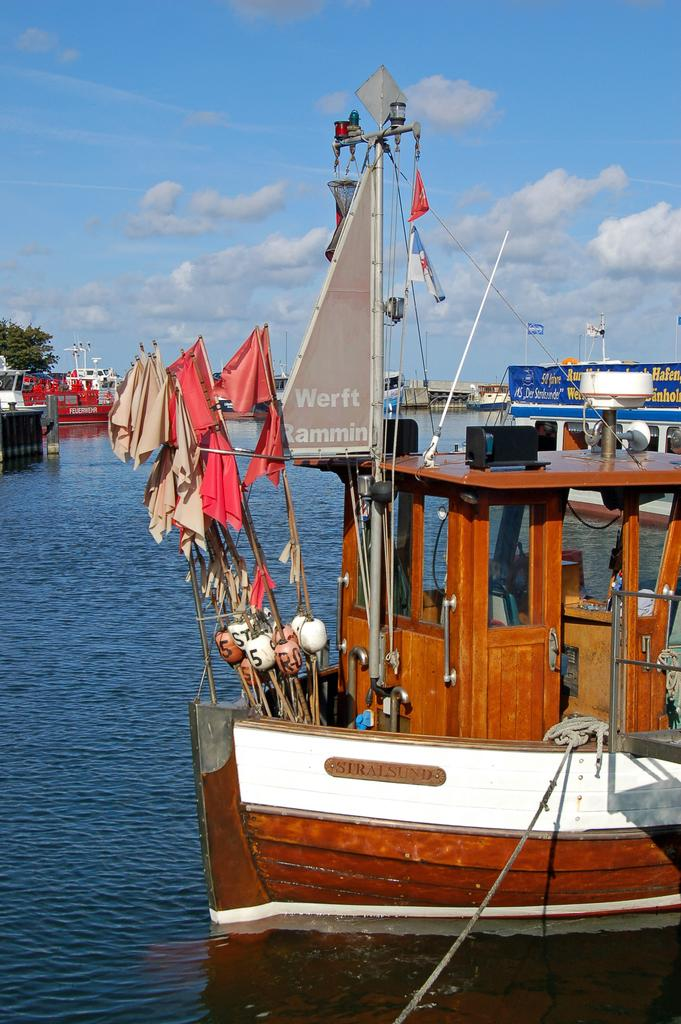<image>
Provide a brief description of the given image. The sail on this ship reads Werft Rammin. 